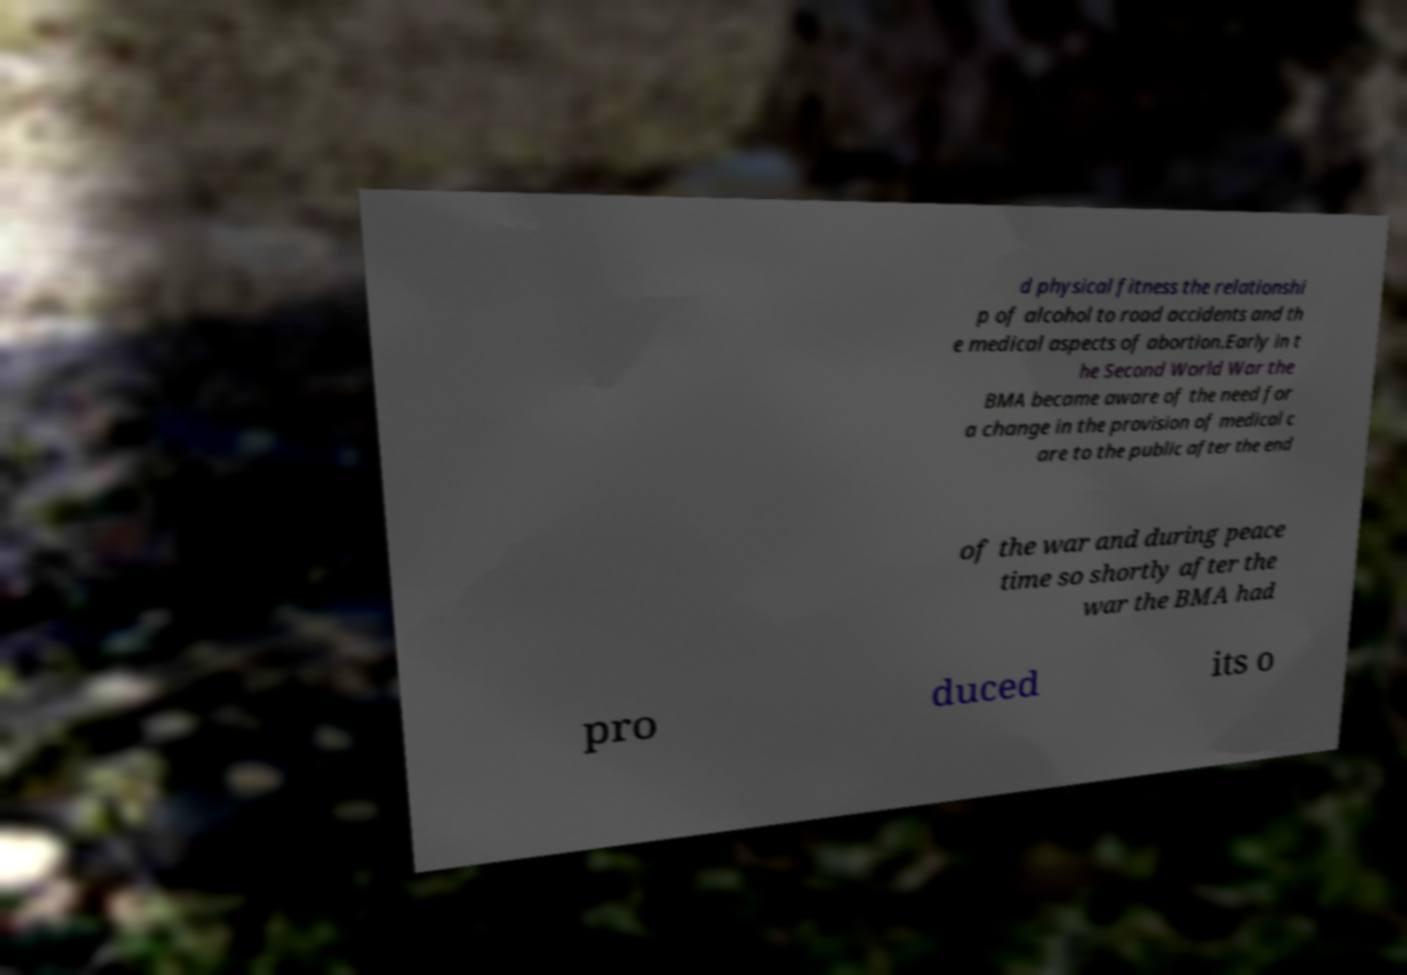Can you accurately transcribe the text from the provided image for me? d physical fitness the relationshi p of alcohol to road accidents and th e medical aspects of abortion.Early in t he Second World War the BMA became aware of the need for a change in the provision of medical c are to the public after the end of the war and during peace time so shortly after the war the BMA had pro duced its o 